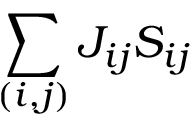Convert formula to latex. <formula><loc_0><loc_0><loc_500><loc_500>\sum _ { ( i , j ) } J _ { i j } S _ { i j }</formula> 